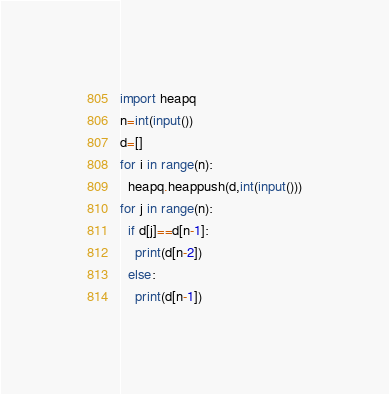Convert code to text. <code><loc_0><loc_0><loc_500><loc_500><_Python_>import heapq
n=int(input())
d=[]
for i in range(n):
  heapq.heappush(d,int(input()))
for j in range(n):
  if d[j]==d[n-1]:
    print(d[n-2])
  else:
    print(d[n-1])</code> 